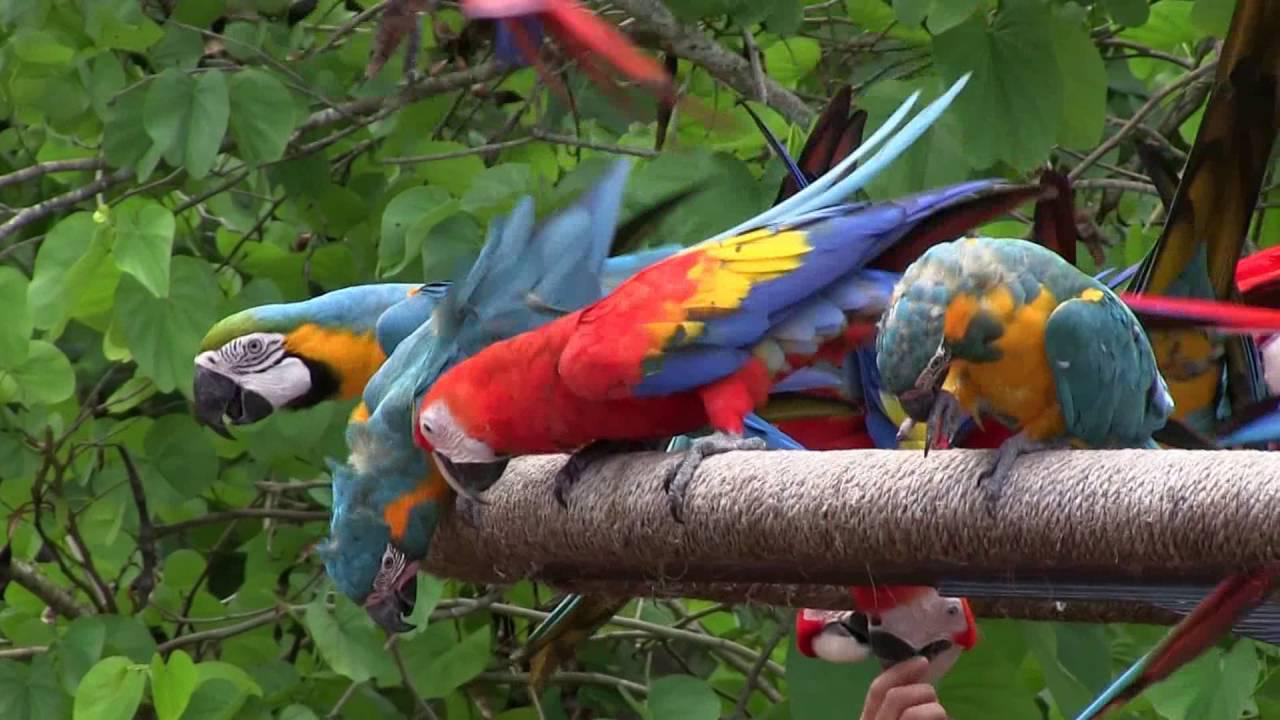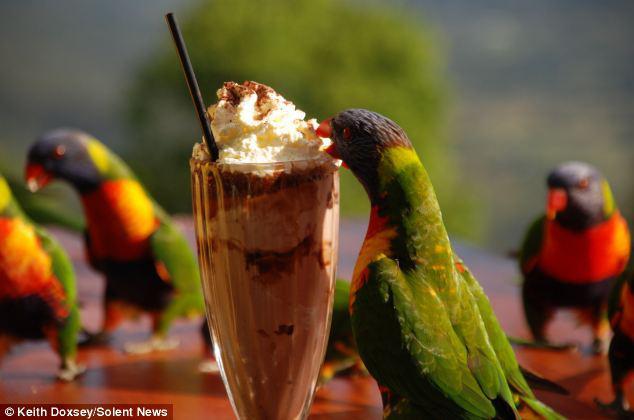The first image is the image on the left, the second image is the image on the right. Given the left and right images, does the statement "In one image, parrots are shown with a tall ice cream dessert." hold true? Answer yes or no. Yes. The first image is the image on the left, the second image is the image on the right. Examine the images to the left and right. Is the description "there are many birds perched on the side of a cliff in one of the images." accurate? Answer yes or no. No. 